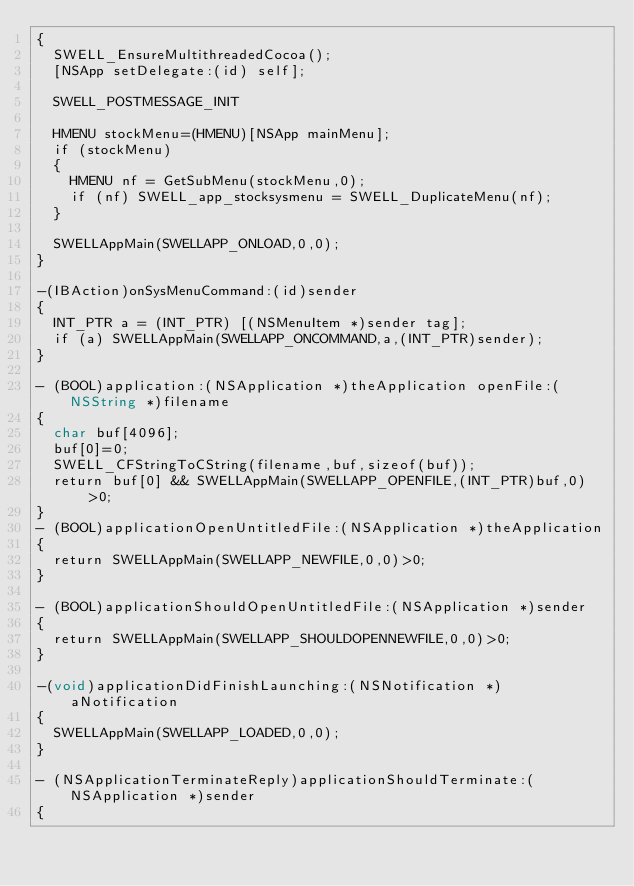<code> <loc_0><loc_0><loc_500><loc_500><_ObjectiveC_>{      
  SWELL_EnsureMultithreadedCocoa();
  [NSApp setDelegate:(id) self];

  SWELL_POSTMESSAGE_INIT
  
  HMENU stockMenu=(HMENU)[NSApp mainMenu];
  if (stockMenu)
  {
    HMENU nf = GetSubMenu(stockMenu,0);
    if (nf) SWELL_app_stocksysmenu = SWELL_DuplicateMenu(nf);
  }
  
  SWELLAppMain(SWELLAPP_ONLOAD,0,0);
}

-(IBAction)onSysMenuCommand:(id)sender
{
  INT_PTR a = (INT_PTR) [(NSMenuItem *)sender tag];
  if (a) SWELLAppMain(SWELLAPP_ONCOMMAND,a,(INT_PTR)sender);
}

- (BOOL)application:(NSApplication *)theApplication openFile:(NSString *)filename
{
  char buf[4096];
  buf[0]=0;
  SWELL_CFStringToCString(filename,buf,sizeof(buf));
  return buf[0] && SWELLAppMain(SWELLAPP_OPENFILE,(INT_PTR)buf,0)>0;
}
- (BOOL)applicationOpenUntitledFile:(NSApplication *)theApplication
{
  return SWELLAppMain(SWELLAPP_NEWFILE,0,0)>0; 
}

- (BOOL)applicationShouldOpenUntitledFile:(NSApplication *)sender
{
  return SWELLAppMain(SWELLAPP_SHOULDOPENNEWFILE,0,0)>0;
}

-(void)applicationDidFinishLaunching:(NSNotification *)aNotification
{
  SWELLAppMain(SWELLAPP_LOADED,0,0);
}

- (NSApplicationTerminateReply)applicationShouldTerminate:(NSApplication *)sender
{</code> 